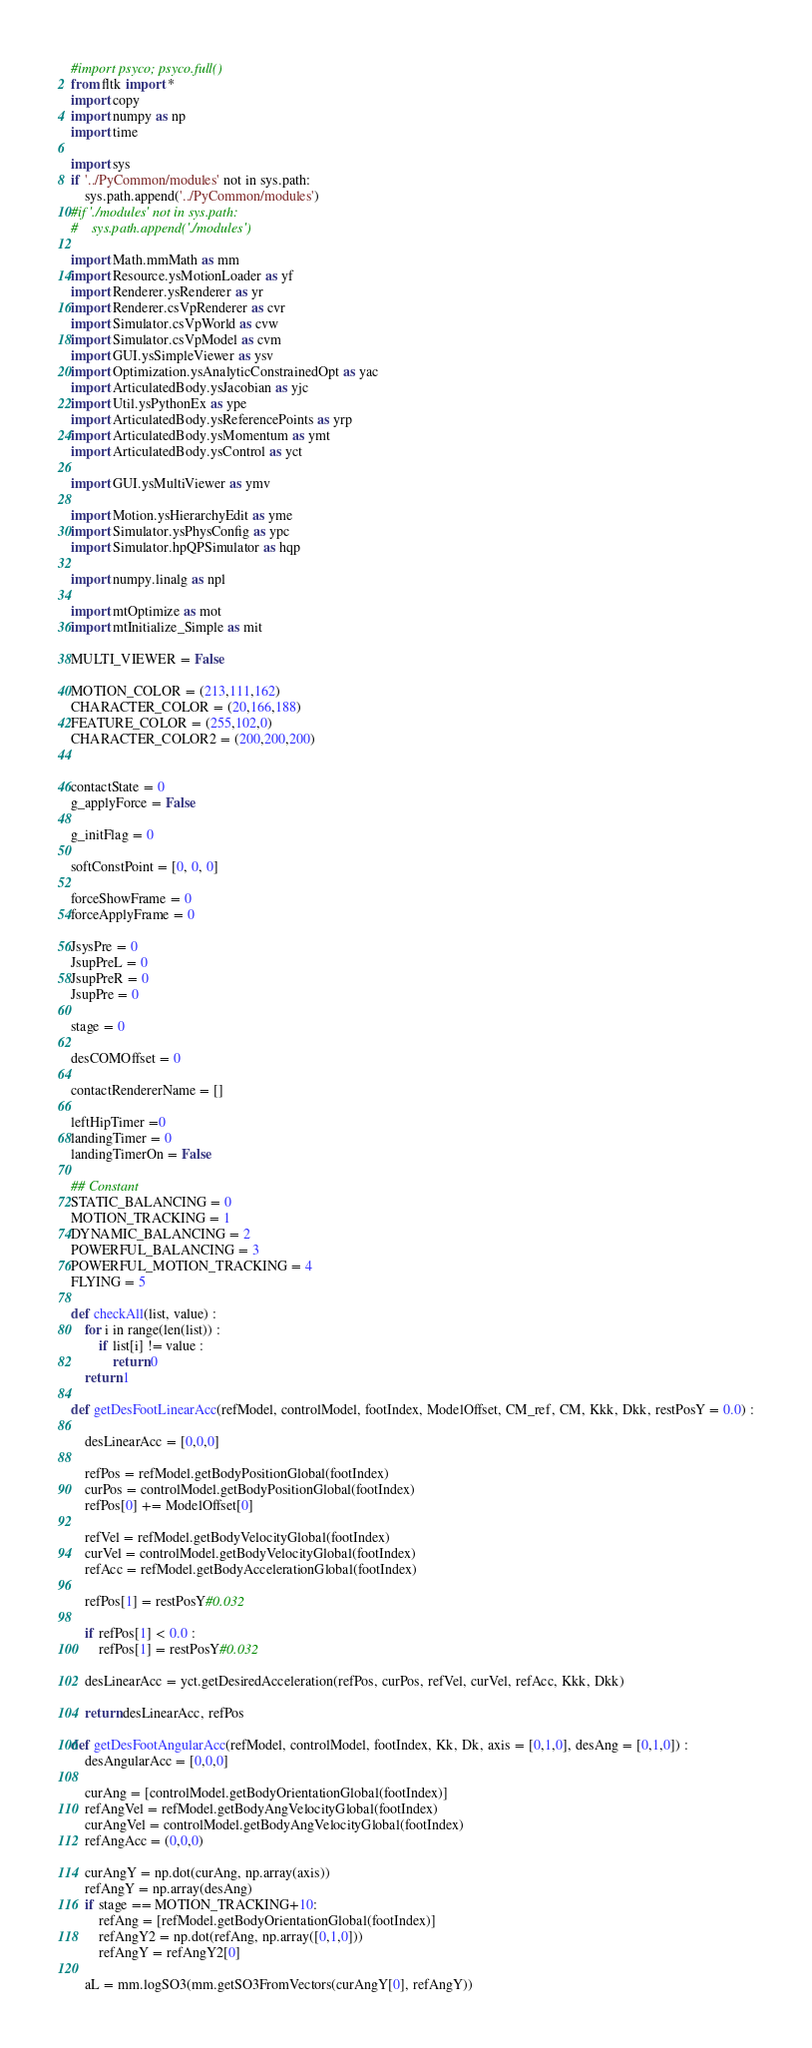Convert code to text. <code><loc_0><loc_0><loc_500><loc_500><_Python_>#import psyco; psyco.full()
from fltk import *
import copy
import numpy as np
import time

import sys
if '../PyCommon/modules' not in sys.path:
    sys.path.append('../PyCommon/modules')
#if './modules' not in sys.path:
#    sys.path.append('./modules')
    
import Math.mmMath as mm
import Resource.ysMotionLoader as yf
import Renderer.ysRenderer as yr
import Renderer.csVpRenderer as cvr
import Simulator.csVpWorld as cvw
import Simulator.csVpModel as cvm
import GUI.ysSimpleViewer as ysv
import Optimization.ysAnalyticConstrainedOpt as yac
import ArticulatedBody.ysJacobian as yjc
import Util.ysPythonEx as ype
import ArticulatedBody.ysReferencePoints as yrp
import ArticulatedBody.ysMomentum as ymt
import ArticulatedBody.ysControl as yct

import GUI.ysMultiViewer as ymv

import Motion.ysHierarchyEdit as yme
import Simulator.ysPhysConfig as ypc
import Simulator.hpQPSimulator as hqp

import numpy.linalg as npl

import mtOptimize as mot
import mtInitialize_Simple as mit

MULTI_VIEWER = False

MOTION_COLOR = (213,111,162)
CHARACTER_COLOR = (20,166,188)
FEATURE_COLOR = (255,102,0)
CHARACTER_COLOR2 = (200,200,200)


contactState = 0
g_applyForce = False

g_initFlag = 0

softConstPoint = [0, 0, 0]

forceShowFrame = 0
forceApplyFrame = 0

JsysPre = 0
JsupPreL = 0
JsupPreR = 0
JsupPre = 0

stage = 0

desCOMOffset = 0

contactRendererName = []

leftHipTimer =0
landingTimer = 0
landingTimerOn = False

## Constant
STATIC_BALANCING = 0
MOTION_TRACKING = 1
DYNAMIC_BALANCING = 2
POWERFUL_BALANCING = 3
POWERFUL_MOTION_TRACKING = 4
FLYING = 5

def checkAll(list, value) :
    for i in range(len(list)) :
        if list[i] != value :
            return 0
    return 1

def getDesFootLinearAcc(refModel, controlModel, footIndex, ModelOffset, CM_ref, CM, Kkk, Dkk, restPosY = 0.0) :
        
    desLinearAcc = [0,0,0]

    refPos = refModel.getBodyPositionGlobal(footIndex)  
    curPos = controlModel.getBodyPositionGlobal(footIndex)
    refPos[0] += ModelOffset[0]
                                
    refVel = refModel.getBodyVelocityGlobal(footIndex) 
    curVel = controlModel.getBodyVelocityGlobal(footIndex)
    refAcc = refModel.getBodyAccelerationGlobal(footIndex)
         
    refPos[1] = restPosY#0.032
        
    if refPos[1] < 0.0 :
        refPos[1] = restPosY#0.032
        
    desLinearAcc = yct.getDesiredAcceleration(refPos, curPos, refVel, curVel, refAcc, Kkk, Dkk)         

    return desLinearAcc, refPos

def getDesFootAngularAcc(refModel, controlModel, footIndex, Kk, Dk, axis = [0,1,0], desAng = [0,1,0]) :
    desAngularAcc = [0,0,0]

    curAng = [controlModel.getBodyOrientationGlobal(footIndex)]
    refAngVel = refModel.getBodyAngVelocityGlobal(footIndex)
    curAngVel = controlModel.getBodyAngVelocityGlobal(footIndex)
    refAngAcc = (0,0,0)
                        
    curAngY = np.dot(curAng, np.array(axis))
    refAngY = np.array(desAng)
    if stage == MOTION_TRACKING+10:    
        refAng = [refModel.getBodyOrientationGlobal(footIndex)]
        refAngY2 = np.dot(refAng, np.array([0,1,0]))
        refAngY = refAngY2[0]
    
    aL = mm.logSO3(mm.getSO3FromVectors(curAngY[0], refAngY))</code> 